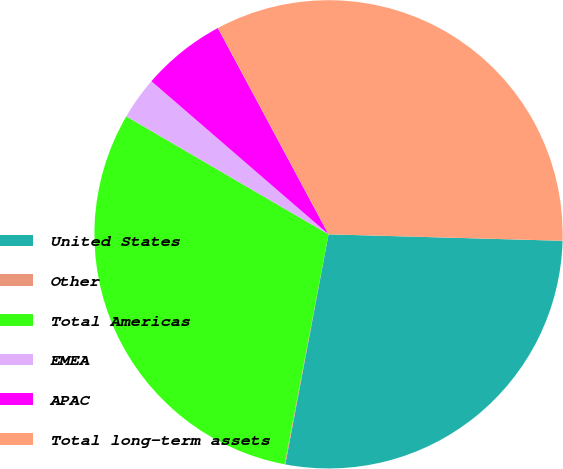<chart> <loc_0><loc_0><loc_500><loc_500><pie_chart><fcel>United States<fcel>Other<fcel>Total Americas<fcel>EMEA<fcel>APAC<fcel>Total long-term assets<nl><fcel>27.52%<fcel>0.05%<fcel>30.4%<fcel>2.94%<fcel>5.82%<fcel>33.28%<nl></chart> 